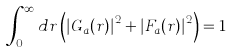Convert formula to latex. <formula><loc_0><loc_0><loc_500><loc_500>\int _ { 0 } ^ { \infty } d r \left ( \left | G _ { a } ( r ) \right | ^ { 2 } + \left | F _ { a } ( r ) \right | ^ { 2 } \right ) = 1</formula> 